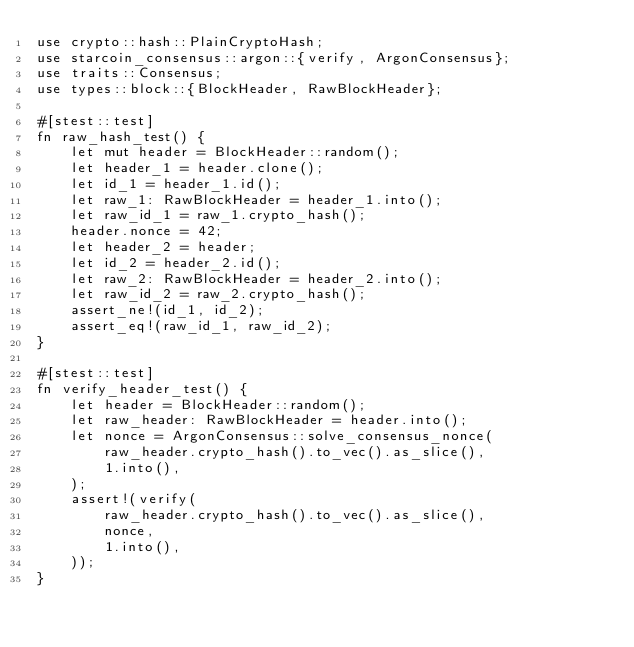<code> <loc_0><loc_0><loc_500><loc_500><_Rust_>use crypto::hash::PlainCryptoHash;
use starcoin_consensus::argon::{verify, ArgonConsensus};
use traits::Consensus;
use types::block::{BlockHeader, RawBlockHeader};

#[stest::test]
fn raw_hash_test() {
    let mut header = BlockHeader::random();
    let header_1 = header.clone();
    let id_1 = header_1.id();
    let raw_1: RawBlockHeader = header_1.into();
    let raw_id_1 = raw_1.crypto_hash();
    header.nonce = 42;
    let header_2 = header;
    let id_2 = header_2.id();
    let raw_2: RawBlockHeader = header_2.into();
    let raw_id_2 = raw_2.crypto_hash();
    assert_ne!(id_1, id_2);
    assert_eq!(raw_id_1, raw_id_2);
}

#[stest::test]
fn verify_header_test() {
    let header = BlockHeader::random();
    let raw_header: RawBlockHeader = header.into();
    let nonce = ArgonConsensus::solve_consensus_nonce(
        raw_header.crypto_hash().to_vec().as_slice(),
        1.into(),
    );
    assert!(verify(
        raw_header.crypto_hash().to_vec().as_slice(),
        nonce,
        1.into(),
    ));
}
</code> 